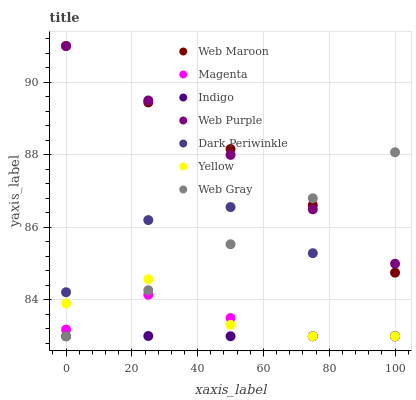Does Indigo have the minimum area under the curve?
Answer yes or no. Yes. Does Web Maroon have the maximum area under the curve?
Answer yes or no. Yes. Does Web Maroon have the minimum area under the curve?
Answer yes or no. No. Does Indigo have the maximum area under the curve?
Answer yes or no. No. Is Web Purple the smoothest?
Answer yes or no. Yes. Is Dark Periwinkle the roughest?
Answer yes or no. Yes. Is Indigo the smoothest?
Answer yes or no. No. Is Indigo the roughest?
Answer yes or no. No. Does Web Gray have the lowest value?
Answer yes or no. Yes. Does Web Maroon have the lowest value?
Answer yes or no. No. Does Web Purple have the highest value?
Answer yes or no. Yes. Does Indigo have the highest value?
Answer yes or no. No. Is Magenta less than Web Maroon?
Answer yes or no. Yes. Is Web Maroon greater than Dark Periwinkle?
Answer yes or no. Yes. Does Magenta intersect Web Gray?
Answer yes or no. Yes. Is Magenta less than Web Gray?
Answer yes or no. No. Is Magenta greater than Web Gray?
Answer yes or no. No. Does Magenta intersect Web Maroon?
Answer yes or no. No. 